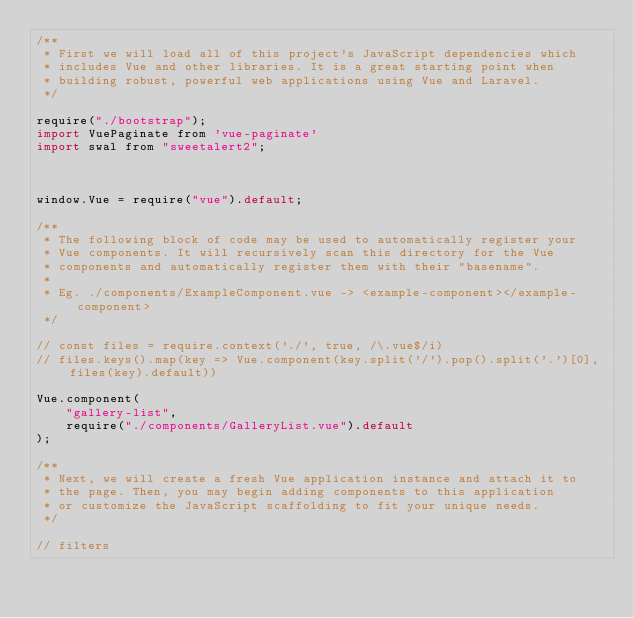<code> <loc_0><loc_0><loc_500><loc_500><_JavaScript_>/**
 * First we will load all of this project's JavaScript dependencies which
 * includes Vue and other libraries. It is a great starting point when
 * building robust, powerful web applications using Vue and Laravel.
 */

require("./bootstrap");
import VuePaginate from 'vue-paginate'
import swal from "sweetalert2";



window.Vue = require("vue").default;

/**
 * The following block of code may be used to automatically register your
 * Vue components. It will recursively scan this directory for the Vue
 * components and automatically register them with their "basename".
 *
 * Eg. ./components/ExampleComponent.vue -> <example-component></example-component>
 */

// const files = require.context('./', true, /\.vue$/i)
// files.keys().map(key => Vue.component(key.split('/').pop().split('.')[0], files(key).default))

Vue.component(
    "gallery-list",
    require("./components/GalleryList.vue").default
);

/**
 * Next, we will create a fresh Vue application instance and attach it to
 * the page. Then, you may begin adding components to this application
 * or customize the JavaScript scaffolding to fit your unique needs.
 */

// filters
</code> 